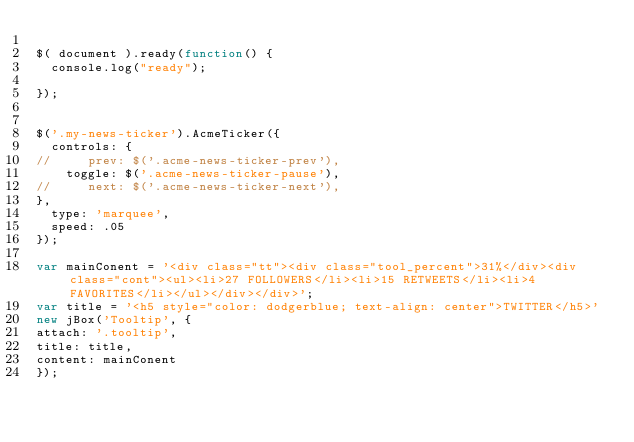Convert code to text. <code><loc_0><loc_0><loc_500><loc_500><_JavaScript_>
$( document ).ready(function() {
  console.log("ready");

});


$('.my-news-ticker').AcmeTicker({
  controls: {
//     prev: $('.acme-news-ticker-prev'),
    toggle: $('.acme-news-ticker-pause'),
//     next: $('.acme-news-ticker-next'),
},
  type: 'marquee',
  speed: .05
});

var mainConent = '<div class="tt"><div class="tool_percent">31%</div><div class="cont"><ul><li>27 FOLLOWERS</li><li>15 RETWEETS</li><li>4 FAVORITES</li></ul></div></div>';
var title = '<h5 style="color: dodgerblue; text-align: center">TWITTER</h5>'
new jBox('Tooltip', {
attach: '.tooltip',
title: title,
content: mainConent
});
</code> 